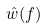<formula> <loc_0><loc_0><loc_500><loc_500>\hat { w } ( f )</formula> 